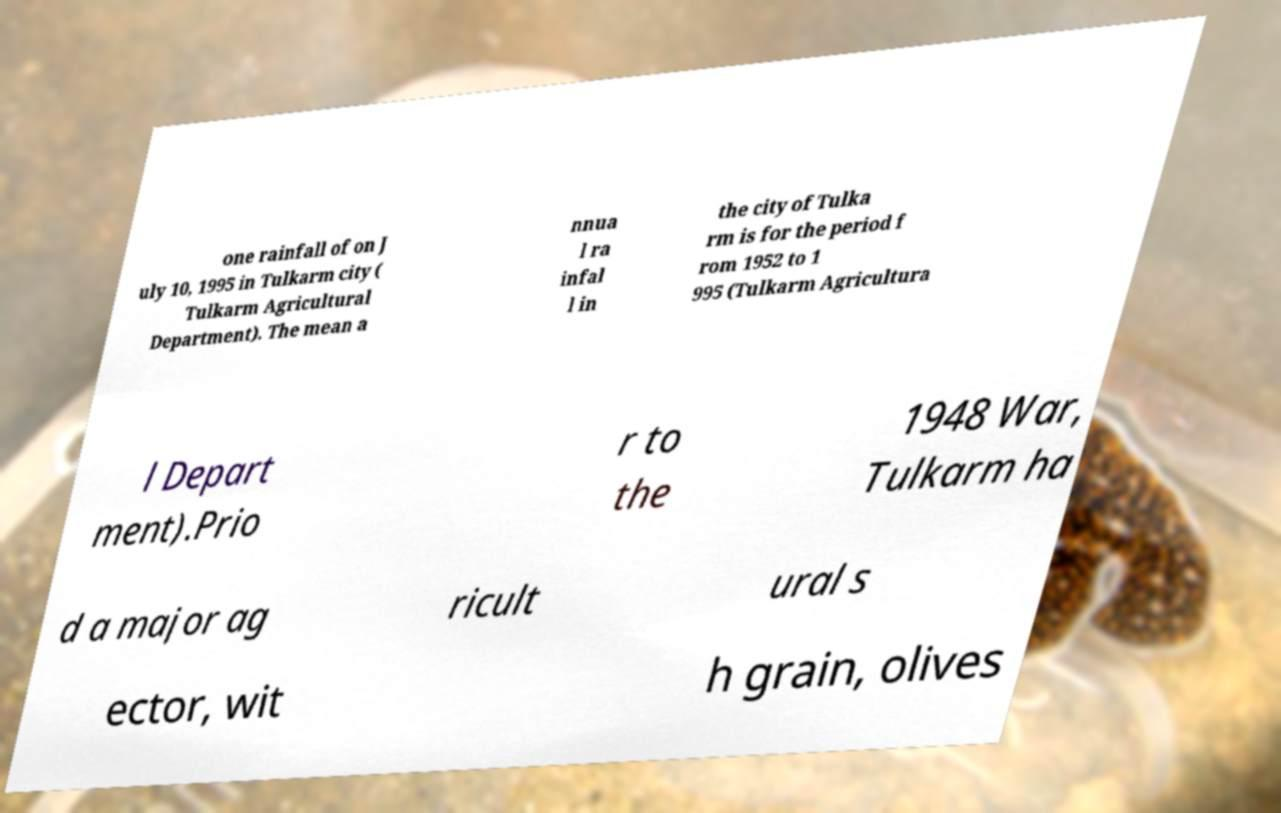What messages or text are displayed in this image? I need them in a readable, typed format. one rainfall of on J uly 10, 1995 in Tulkarm city ( Tulkarm Agricultural Department). The mean a nnua l ra infal l in the city of Tulka rm is for the period f rom 1952 to 1 995 (Tulkarm Agricultura l Depart ment).Prio r to the 1948 War, Tulkarm ha d a major ag ricult ural s ector, wit h grain, olives 